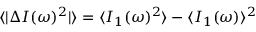<formula> <loc_0><loc_0><loc_500><loc_500>\langle | \Delta I ( \omega ) ^ { 2 } | \rangle = \langle I _ { 1 } ( \omega ) ^ { 2 } \rangle - \langle I _ { 1 } ( \omega ) \rangle ^ { 2 }</formula> 